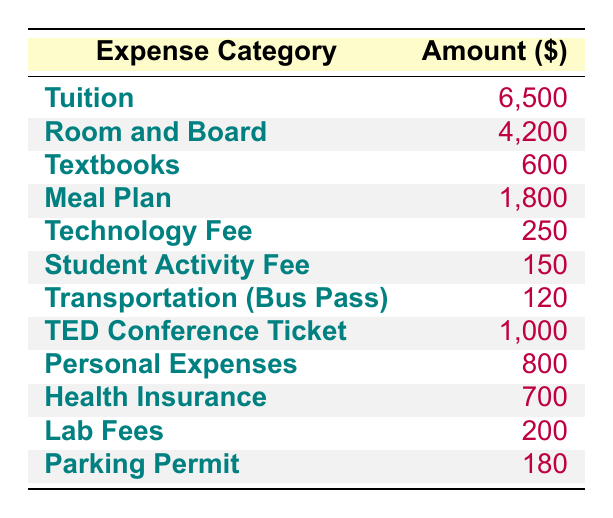What is the total cost of tuition and room and board? To find the total cost, we sum the amounts for tuition ($6500) and room and board ($4200). So, 6500 + 4200 = 10700.
Answer: 10700 How much does the meal plan cost compared to textbooks? The meal plan costs $1800, while textbooks cost $600. To compare, 1800 - 600 = 1200, showing the meal plan costs $1200 more than the textbooks.
Answer: 1200 Is the transportation cost greater than the parking permit fee? Transportation (Bus Pass) costs $120, while the Parking Permit costs $180. Since 120 is less than 180, the transportation cost is not greater.
Answer: No What is the combined cost of personal expenses and health insurance? We add the costs for personal expenses ($800) and health insurance ($700). So, 800 + 700 = 1500.
Answer: 1500 What is the total amount spent on textbooks, lab fees, and the technology fee? To find the total, we add the amounts for textbooks ($600), lab fees ($200), and the technology fee ($250). So, 600 + 200 + 250 = 1050.
Answer: 1050 What is the most expensive single expense category? By examining the amounts, tuition ($6500) is greater than all other categories listed. Thus, it is the most expensive single category.
Answer: Tuition Are personal expenses and the student activity fee greater than the transportation cost combined? The total for personal expenses ($800) and the student activity fee ($150) is 800 + 150 = 950. The transportation cost is $120. Since 950 is greater than 120, the statement is true.
Answer: Yes What percentage of the total expenses is spent on the TED Conference Ticket? The total expenses are the sum of all categories, which equals $20,900. The TED Conference Ticket costs $1000. To find the percentage, we calculate (1000 / 20900) * 100 ≈ 4.78%.
Answer: 4.78% 